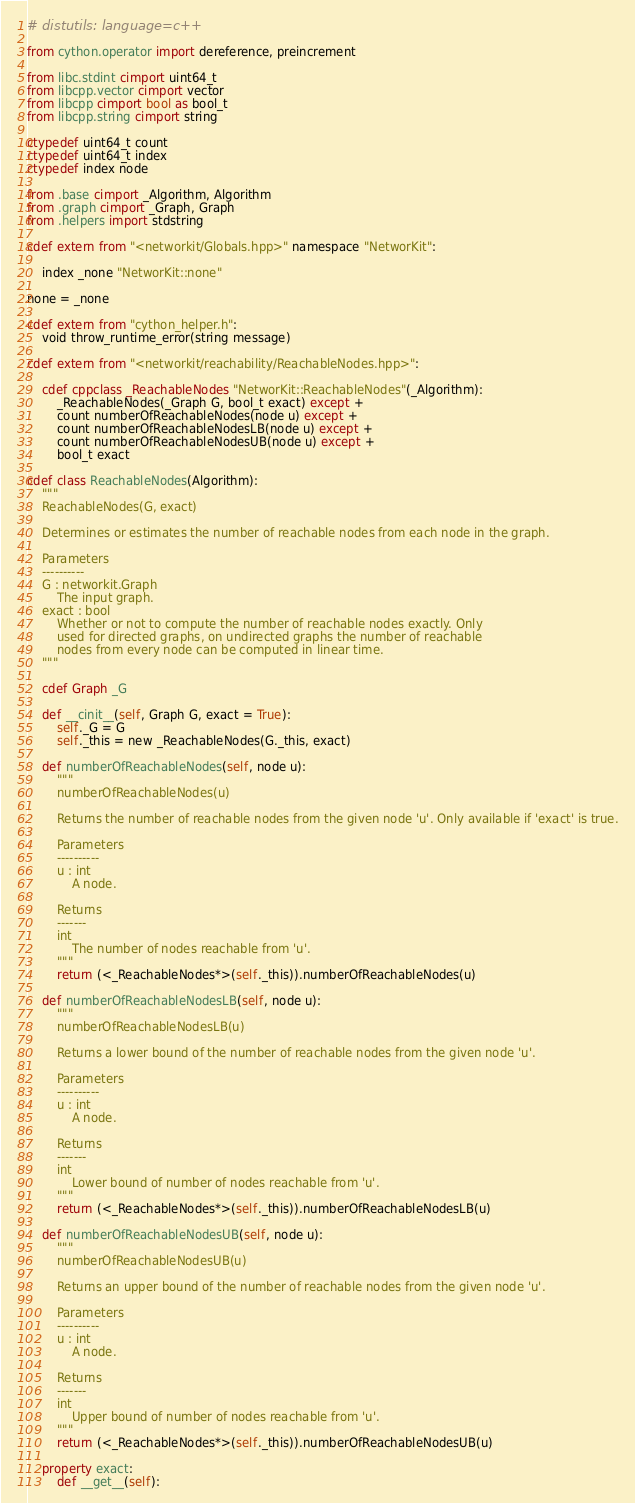Convert code to text. <code><loc_0><loc_0><loc_500><loc_500><_Cython_># distutils: language=c++

from cython.operator import dereference, preincrement

from libc.stdint cimport uint64_t
from libcpp.vector cimport vector
from libcpp cimport bool as bool_t
from libcpp.string cimport string

ctypedef uint64_t count
ctypedef uint64_t index
ctypedef index node

from .base cimport _Algorithm, Algorithm
from .graph cimport _Graph, Graph
from .helpers import stdstring

cdef extern from "<networkit/Globals.hpp>" namespace "NetworKit":

	index _none "NetworKit::none"

none = _none

cdef extern from "cython_helper.h":
	void throw_runtime_error(string message)

cdef extern from "<networkit/reachability/ReachableNodes.hpp>":

	cdef cppclass _ReachableNodes "NetworKit::ReachableNodes"(_Algorithm):
		_ReachableNodes(_Graph G, bool_t exact) except +
		count numberOfReachableNodes(node u) except +
		count numberOfReachableNodesLB(node u) except +
		count numberOfReachableNodesUB(node u) except +
		bool_t exact

cdef class ReachableNodes(Algorithm):
	"""
	ReachableNodes(G, exact)	

	Determines or estimates the number of reachable nodes from each node in the graph.

	Parameters
	----------
	G : networkit.Graph
		The input graph.
	exact : bool
		Whether or not to compute the number of reachable nodes exactly. Only
		used for directed graphs, on undirected graphs the number of reachable
		nodes from every node can be computed in linear time.
	"""

	cdef Graph _G

	def __cinit__(self, Graph G, exact = True):
		self._G = G
		self._this = new _ReachableNodes(G._this, exact)

	def numberOfReachableNodes(self, node u):
		"""
		numberOfReachableNodes(u)

		Returns the number of reachable nodes from the given node 'u'. Only available if 'exact' is true.

		Parameters
		----------
		u : int
			A node.

		Returns
		-------
		int
			The number of nodes reachable from 'u'.
		"""
		return (<_ReachableNodes*>(self._this)).numberOfReachableNodes(u)

	def numberOfReachableNodesLB(self, node u):
		"""
		numberOfReachableNodesLB(u)

		Returns a lower bound of the number of reachable nodes from the given node 'u'.

		Parameters
		----------
		u : int
			A node.

		Returns
		-------
		int
			Lower bound of number of nodes reachable from 'u'.
		"""
		return (<_ReachableNodes*>(self._this)).numberOfReachableNodesLB(u)

	def numberOfReachableNodesUB(self, node u):
		"""
		numberOfReachableNodesUB(u)

		Returns an upper bound of the number of reachable nodes from the given node 'u'.

		Parameters
		----------
		u : int
			A node.

		Returns
		-------
		int
			Upper bound of number of nodes reachable from 'u'.
		"""
		return (<_ReachableNodes*>(self._this)).numberOfReachableNodesUB(u)

	property exact:
		def __get__(self):</code> 